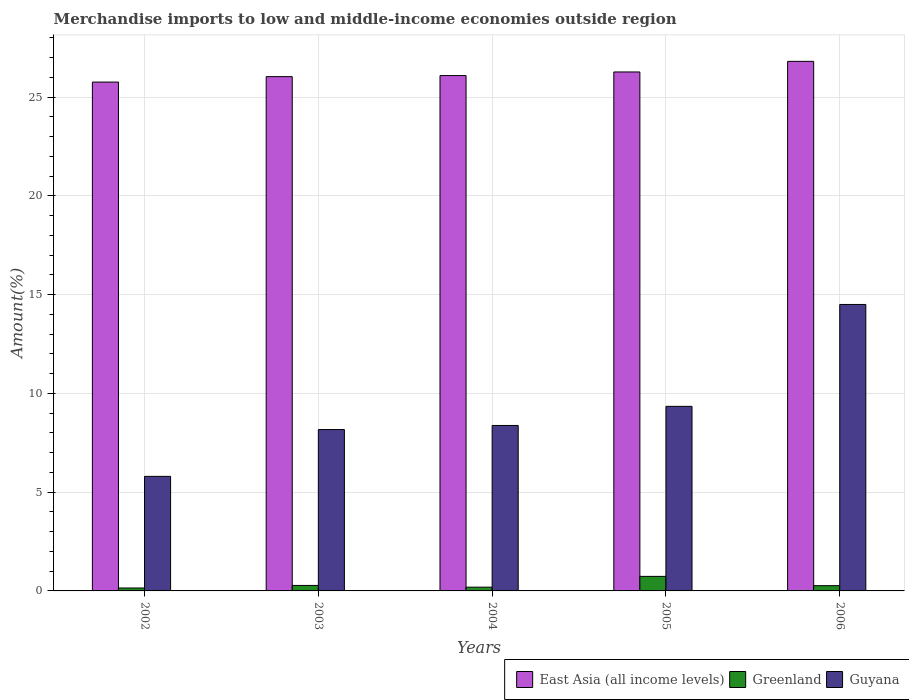How many different coloured bars are there?
Make the answer very short. 3. How many groups of bars are there?
Provide a succinct answer. 5. Are the number of bars on each tick of the X-axis equal?
Make the answer very short. Yes. How many bars are there on the 2nd tick from the left?
Your answer should be very brief. 3. How many bars are there on the 3rd tick from the right?
Offer a very short reply. 3. What is the label of the 5th group of bars from the left?
Keep it short and to the point. 2006. What is the percentage of amount earned from merchandise imports in Greenland in 2003?
Provide a short and direct response. 0.28. Across all years, what is the maximum percentage of amount earned from merchandise imports in Greenland?
Provide a succinct answer. 0.74. Across all years, what is the minimum percentage of amount earned from merchandise imports in Greenland?
Your response must be concise. 0.15. In which year was the percentage of amount earned from merchandise imports in East Asia (all income levels) minimum?
Your answer should be compact. 2002. What is the total percentage of amount earned from merchandise imports in Guyana in the graph?
Provide a short and direct response. 46.19. What is the difference between the percentage of amount earned from merchandise imports in Greenland in 2003 and that in 2006?
Offer a terse response. 0.01. What is the difference between the percentage of amount earned from merchandise imports in Greenland in 2005 and the percentage of amount earned from merchandise imports in East Asia (all income levels) in 2003?
Offer a terse response. -25.3. What is the average percentage of amount earned from merchandise imports in East Asia (all income levels) per year?
Your answer should be very brief. 26.19. In the year 2003, what is the difference between the percentage of amount earned from merchandise imports in Guyana and percentage of amount earned from merchandise imports in Greenland?
Keep it short and to the point. 7.89. In how many years, is the percentage of amount earned from merchandise imports in Guyana greater than 10 %?
Make the answer very short. 1. What is the ratio of the percentage of amount earned from merchandise imports in Guyana in 2002 to that in 2004?
Make the answer very short. 0.69. Is the percentage of amount earned from merchandise imports in Guyana in 2004 less than that in 2005?
Keep it short and to the point. Yes. Is the difference between the percentage of amount earned from merchandise imports in Guyana in 2004 and 2005 greater than the difference between the percentage of amount earned from merchandise imports in Greenland in 2004 and 2005?
Offer a terse response. No. What is the difference between the highest and the second highest percentage of amount earned from merchandise imports in Greenland?
Your answer should be very brief. 0.46. What is the difference between the highest and the lowest percentage of amount earned from merchandise imports in Greenland?
Provide a short and direct response. 0.59. In how many years, is the percentage of amount earned from merchandise imports in Guyana greater than the average percentage of amount earned from merchandise imports in Guyana taken over all years?
Give a very brief answer. 2. Is the sum of the percentage of amount earned from merchandise imports in Guyana in 2005 and 2006 greater than the maximum percentage of amount earned from merchandise imports in Greenland across all years?
Your answer should be compact. Yes. What does the 3rd bar from the left in 2002 represents?
Give a very brief answer. Guyana. What does the 2nd bar from the right in 2002 represents?
Keep it short and to the point. Greenland. How many bars are there?
Your response must be concise. 15. Are all the bars in the graph horizontal?
Provide a succinct answer. No. Are the values on the major ticks of Y-axis written in scientific E-notation?
Offer a terse response. No. Where does the legend appear in the graph?
Provide a short and direct response. Bottom right. How are the legend labels stacked?
Offer a very short reply. Horizontal. What is the title of the graph?
Keep it short and to the point. Merchandise imports to low and middle-income economies outside region. What is the label or title of the Y-axis?
Your answer should be compact. Amount(%). What is the Amount(%) of East Asia (all income levels) in 2002?
Keep it short and to the point. 25.76. What is the Amount(%) of Greenland in 2002?
Offer a very short reply. 0.15. What is the Amount(%) of Guyana in 2002?
Provide a succinct answer. 5.8. What is the Amount(%) in East Asia (all income levels) in 2003?
Make the answer very short. 26.03. What is the Amount(%) in Greenland in 2003?
Keep it short and to the point. 0.28. What is the Amount(%) in Guyana in 2003?
Your response must be concise. 8.17. What is the Amount(%) of East Asia (all income levels) in 2004?
Provide a short and direct response. 26.09. What is the Amount(%) in Greenland in 2004?
Your answer should be compact. 0.19. What is the Amount(%) in Guyana in 2004?
Offer a very short reply. 8.38. What is the Amount(%) of East Asia (all income levels) in 2005?
Make the answer very short. 26.27. What is the Amount(%) of Greenland in 2005?
Offer a very short reply. 0.74. What is the Amount(%) in Guyana in 2005?
Make the answer very short. 9.34. What is the Amount(%) of East Asia (all income levels) in 2006?
Ensure brevity in your answer.  26.81. What is the Amount(%) in Greenland in 2006?
Offer a very short reply. 0.27. What is the Amount(%) of Guyana in 2006?
Provide a succinct answer. 14.5. Across all years, what is the maximum Amount(%) in East Asia (all income levels)?
Keep it short and to the point. 26.81. Across all years, what is the maximum Amount(%) in Greenland?
Your answer should be very brief. 0.74. Across all years, what is the maximum Amount(%) in Guyana?
Provide a succinct answer. 14.5. Across all years, what is the minimum Amount(%) in East Asia (all income levels)?
Your answer should be compact. 25.76. Across all years, what is the minimum Amount(%) of Greenland?
Provide a short and direct response. 0.15. Across all years, what is the minimum Amount(%) of Guyana?
Provide a succinct answer. 5.8. What is the total Amount(%) in East Asia (all income levels) in the graph?
Keep it short and to the point. 130.95. What is the total Amount(%) of Greenland in the graph?
Your answer should be compact. 1.62. What is the total Amount(%) in Guyana in the graph?
Offer a terse response. 46.19. What is the difference between the Amount(%) in East Asia (all income levels) in 2002 and that in 2003?
Offer a terse response. -0.28. What is the difference between the Amount(%) of Greenland in 2002 and that in 2003?
Ensure brevity in your answer.  -0.13. What is the difference between the Amount(%) in Guyana in 2002 and that in 2003?
Make the answer very short. -2.37. What is the difference between the Amount(%) in East Asia (all income levels) in 2002 and that in 2004?
Keep it short and to the point. -0.33. What is the difference between the Amount(%) in Greenland in 2002 and that in 2004?
Provide a succinct answer. -0.04. What is the difference between the Amount(%) of Guyana in 2002 and that in 2004?
Offer a very short reply. -2.58. What is the difference between the Amount(%) of East Asia (all income levels) in 2002 and that in 2005?
Offer a terse response. -0.51. What is the difference between the Amount(%) in Greenland in 2002 and that in 2005?
Ensure brevity in your answer.  -0.59. What is the difference between the Amount(%) of Guyana in 2002 and that in 2005?
Your answer should be compact. -3.54. What is the difference between the Amount(%) of East Asia (all income levels) in 2002 and that in 2006?
Keep it short and to the point. -1.05. What is the difference between the Amount(%) of Greenland in 2002 and that in 2006?
Provide a succinct answer. -0.12. What is the difference between the Amount(%) of Guyana in 2002 and that in 2006?
Keep it short and to the point. -8.7. What is the difference between the Amount(%) in East Asia (all income levels) in 2003 and that in 2004?
Keep it short and to the point. -0.05. What is the difference between the Amount(%) of Greenland in 2003 and that in 2004?
Offer a very short reply. 0.09. What is the difference between the Amount(%) of Guyana in 2003 and that in 2004?
Your response must be concise. -0.21. What is the difference between the Amount(%) of East Asia (all income levels) in 2003 and that in 2005?
Keep it short and to the point. -0.24. What is the difference between the Amount(%) of Greenland in 2003 and that in 2005?
Give a very brief answer. -0.46. What is the difference between the Amount(%) in Guyana in 2003 and that in 2005?
Provide a short and direct response. -1.17. What is the difference between the Amount(%) in East Asia (all income levels) in 2003 and that in 2006?
Give a very brief answer. -0.77. What is the difference between the Amount(%) of Greenland in 2003 and that in 2006?
Make the answer very short. 0.01. What is the difference between the Amount(%) of Guyana in 2003 and that in 2006?
Your response must be concise. -6.33. What is the difference between the Amount(%) of East Asia (all income levels) in 2004 and that in 2005?
Keep it short and to the point. -0.18. What is the difference between the Amount(%) in Greenland in 2004 and that in 2005?
Give a very brief answer. -0.55. What is the difference between the Amount(%) of Guyana in 2004 and that in 2005?
Your answer should be very brief. -0.97. What is the difference between the Amount(%) of East Asia (all income levels) in 2004 and that in 2006?
Offer a very short reply. -0.72. What is the difference between the Amount(%) of Greenland in 2004 and that in 2006?
Your answer should be very brief. -0.08. What is the difference between the Amount(%) of Guyana in 2004 and that in 2006?
Provide a succinct answer. -6.13. What is the difference between the Amount(%) of East Asia (all income levels) in 2005 and that in 2006?
Ensure brevity in your answer.  -0.54. What is the difference between the Amount(%) of Greenland in 2005 and that in 2006?
Provide a succinct answer. 0.47. What is the difference between the Amount(%) in Guyana in 2005 and that in 2006?
Ensure brevity in your answer.  -5.16. What is the difference between the Amount(%) in East Asia (all income levels) in 2002 and the Amount(%) in Greenland in 2003?
Make the answer very short. 25.48. What is the difference between the Amount(%) in East Asia (all income levels) in 2002 and the Amount(%) in Guyana in 2003?
Give a very brief answer. 17.59. What is the difference between the Amount(%) of Greenland in 2002 and the Amount(%) of Guyana in 2003?
Your answer should be compact. -8.02. What is the difference between the Amount(%) of East Asia (all income levels) in 2002 and the Amount(%) of Greenland in 2004?
Give a very brief answer. 25.57. What is the difference between the Amount(%) of East Asia (all income levels) in 2002 and the Amount(%) of Guyana in 2004?
Provide a succinct answer. 17.38. What is the difference between the Amount(%) of Greenland in 2002 and the Amount(%) of Guyana in 2004?
Your answer should be compact. -8.23. What is the difference between the Amount(%) of East Asia (all income levels) in 2002 and the Amount(%) of Greenland in 2005?
Keep it short and to the point. 25.02. What is the difference between the Amount(%) of East Asia (all income levels) in 2002 and the Amount(%) of Guyana in 2005?
Give a very brief answer. 16.41. What is the difference between the Amount(%) in Greenland in 2002 and the Amount(%) in Guyana in 2005?
Your response must be concise. -9.19. What is the difference between the Amount(%) in East Asia (all income levels) in 2002 and the Amount(%) in Greenland in 2006?
Give a very brief answer. 25.49. What is the difference between the Amount(%) of East Asia (all income levels) in 2002 and the Amount(%) of Guyana in 2006?
Your answer should be compact. 11.26. What is the difference between the Amount(%) in Greenland in 2002 and the Amount(%) in Guyana in 2006?
Provide a short and direct response. -14.35. What is the difference between the Amount(%) of East Asia (all income levels) in 2003 and the Amount(%) of Greenland in 2004?
Provide a succinct answer. 25.84. What is the difference between the Amount(%) of East Asia (all income levels) in 2003 and the Amount(%) of Guyana in 2004?
Offer a terse response. 17.66. What is the difference between the Amount(%) of Greenland in 2003 and the Amount(%) of Guyana in 2004?
Your answer should be compact. -8.1. What is the difference between the Amount(%) in East Asia (all income levels) in 2003 and the Amount(%) in Greenland in 2005?
Provide a short and direct response. 25.3. What is the difference between the Amount(%) in East Asia (all income levels) in 2003 and the Amount(%) in Guyana in 2005?
Offer a very short reply. 16.69. What is the difference between the Amount(%) in Greenland in 2003 and the Amount(%) in Guyana in 2005?
Your response must be concise. -9.06. What is the difference between the Amount(%) in East Asia (all income levels) in 2003 and the Amount(%) in Greenland in 2006?
Your answer should be compact. 25.77. What is the difference between the Amount(%) of East Asia (all income levels) in 2003 and the Amount(%) of Guyana in 2006?
Your response must be concise. 11.53. What is the difference between the Amount(%) of Greenland in 2003 and the Amount(%) of Guyana in 2006?
Your answer should be very brief. -14.22. What is the difference between the Amount(%) of East Asia (all income levels) in 2004 and the Amount(%) of Greenland in 2005?
Offer a very short reply. 25.35. What is the difference between the Amount(%) of East Asia (all income levels) in 2004 and the Amount(%) of Guyana in 2005?
Give a very brief answer. 16.74. What is the difference between the Amount(%) of Greenland in 2004 and the Amount(%) of Guyana in 2005?
Your response must be concise. -9.15. What is the difference between the Amount(%) of East Asia (all income levels) in 2004 and the Amount(%) of Greenland in 2006?
Provide a succinct answer. 25.82. What is the difference between the Amount(%) in East Asia (all income levels) in 2004 and the Amount(%) in Guyana in 2006?
Provide a succinct answer. 11.59. What is the difference between the Amount(%) in Greenland in 2004 and the Amount(%) in Guyana in 2006?
Give a very brief answer. -14.31. What is the difference between the Amount(%) in East Asia (all income levels) in 2005 and the Amount(%) in Greenland in 2006?
Offer a very short reply. 26. What is the difference between the Amount(%) in East Asia (all income levels) in 2005 and the Amount(%) in Guyana in 2006?
Provide a short and direct response. 11.77. What is the difference between the Amount(%) of Greenland in 2005 and the Amount(%) of Guyana in 2006?
Provide a succinct answer. -13.76. What is the average Amount(%) of East Asia (all income levels) per year?
Your answer should be very brief. 26.19. What is the average Amount(%) in Greenland per year?
Provide a short and direct response. 0.32. What is the average Amount(%) in Guyana per year?
Your response must be concise. 9.24. In the year 2002, what is the difference between the Amount(%) of East Asia (all income levels) and Amount(%) of Greenland?
Your answer should be compact. 25.61. In the year 2002, what is the difference between the Amount(%) of East Asia (all income levels) and Amount(%) of Guyana?
Ensure brevity in your answer.  19.96. In the year 2002, what is the difference between the Amount(%) of Greenland and Amount(%) of Guyana?
Provide a short and direct response. -5.65. In the year 2003, what is the difference between the Amount(%) of East Asia (all income levels) and Amount(%) of Greenland?
Give a very brief answer. 25.75. In the year 2003, what is the difference between the Amount(%) of East Asia (all income levels) and Amount(%) of Guyana?
Provide a short and direct response. 17.86. In the year 2003, what is the difference between the Amount(%) of Greenland and Amount(%) of Guyana?
Give a very brief answer. -7.89. In the year 2004, what is the difference between the Amount(%) in East Asia (all income levels) and Amount(%) in Greenland?
Provide a succinct answer. 25.9. In the year 2004, what is the difference between the Amount(%) in East Asia (all income levels) and Amount(%) in Guyana?
Offer a terse response. 17.71. In the year 2004, what is the difference between the Amount(%) in Greenland and Amount(%) in Guyana?
Make the answer very short. -8.19. In the year 2005, what is the difference between the Amount(%) in East Asia (all income levels) and Amount(%) in Greenland?
Make the answer very short. 25.53. In the year 2005, what is the difference between the Amount(%) in East Asia (all income levels) and Amount(%) in Guyana?
Your answer should be compact. 16.93. In the year 2005, what is the difference between the Amount(%) of Greenland and Amount(%) of Guyana?
Offer a very short reply. -8.61. In the year 2006, what is the difference between the Amount(%) of East Asia (all income levels) and Amount(%) of Greenland?
Provide a short and direct response. 26.54. In the year 2006, what is the difference between the Amount(%) in East Asia (all income levels) and Amount(%) in Guyana?
Ensure brevity in your answer.  12.31. In the year 2006, what is the difference between the Amount(%) in Greenland and Amount(%) in Guyana?
Keep it short and to the point. -14.23. What is the ratio of the Amount(%) in East Asia (all income levels) in 2002 to that in 2003?
Give a very brief answer. 0.99. What is the ratio of the Amount(%) in Greenland in 2002 to that in 2003?
Offer a terse response. 0.54. What is the ratio of the Amount(%) of Guyana in 2002 to that in 2003?
Keep it short and to the point. 0.71. What is the ratio of the Amount(%) of East Asia (all income levels) in 2002 to that in 2004?
Ensure brevity in your answer.  0.99. What is the ratio of the Amount(%) of Greenland in 2002 to that in 2004?
Provide a succinct answer. 0.78. What is the ratio of the Amount(%) in Guyana in 2002 to that in 2004?
Make the answer very short. 0.69. What is the ratio of the Amount(%) of East Asia (all income levels) in 2002 to that in 2005?
Give a very brief answer. 0.98. What is the ratio of the Amount(%) in Greenland in 2002 to that in 2005?
Keep it short and to the point. 0.2. What is the ratio of the Amount(%) of Guyana in 2002 to that in 2005?
Your answer should be compact. 0.62. What is the ratio of the Amount(%) in East Asia (all income levels) in 2002 to that in 2006?
Provide a succinct answer. 0.96. What is the ratio of the Amount(%) of Greenland in 2002 to that in 2006?
Your answer should be compact. 0.56. What is the ratio of the Amount(%) of Guyana in 2002 to that in 2006?
Your answer should be very brief. 0.4. What is the ratio of the Amount(%) of Greenland in 2003 to that in 2004?
Provide a succinct answer. 1.46. What is the ratio of the Amount(%) in Guyana in 2003 to that in 2004?
Your answer should be compact. 0.98. What is the ratio of the Amount(%) in Greenland in 2003 to that in 2005?
Provide a succinct answer. 0.38. What is the ratio of the Amount(%) in Guyana in 2003 to that in 2005?
Provide a short and direct response. 0.87. What is the ratio of the Amount(%) in East Asia (all income levels) in 2003 to that in 2006?
Give a very brief answer. 0.97. What is the ratio of the Amount(%) of Greenland in 2003 to that in 2006?
Your answer should be very brief. 1.04. What is the ratio of the Amount(%) of Guyana in 2003 to that in 2006?
Offer a very short reply. 0.56. What is the ratio of the Amount(%) in Greenland in 2004 to that in 2005?
Make the answer very short. 0.26. What is the ratio of the Amount(%) in Guyana in 2004 to that in 2005?
Your answer should be very brief. 0.9. What is the ratio of the Amount(%) in East Asia (all income levels) in 2004 to that in 2006?
Ensure brevity in your answer.  0.97. What is the ratio of the Amount(%) in Greenland in 2004 to that in 2006?
Keep it short and to the point. 0.71. What is the ratio of the Amount(%) of Guyana in 2004 to that in 2006?
Provide a succinct answer. 0.58. What is the ratio of the Amount(%) in Greenland in 2005 to that in 2006?
Your answer should be compact. 2.76. What is the ratio of the Amount(%) in Guyana in 2005 to that in 2006?
Give a very brief answer. 0.64. What is the difference between the highest and the second highest Amount(%) of East Asia (all income levels)?
Provide a succinct answer. 0.54. What is the difference between the highest and the second highest Amount(%) in Greenland?
Offer a terse response. 0.46. What is the difference between the highest and the second highest Amount(%) of Guyana?
Provide a succinct answer. 5.16. What is the difference between the highest and the lowest Amount(%) in East Asia (all income levels)?
Provide a short and direct response. 1.05. What is the difference between the highest and the lowest Amount(%) of Greenland?
Provide a short and direct response. 0.59. What is the difference between the highest and the lowest Amount(%) of Guyana?
Offer a very short reply. 8.7. 